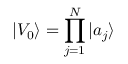Convert formula to latex. <formula><loc_0><loc_0><loc_500><loc_500>| V _ { 0 } \rangle = \prod _ { j = 1 } ^ { N } | a _ { j } \rangle</formula> 